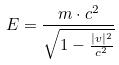Convert formula to latex. <formula><loc_0><loc_0><loc_500><loc_500>E = \frac { m \cdot c ^ { 2 } } { \sqrt { 1 - \frac { | v | ^ { 2 } } { c ^ { 2 } } } }</formula> 